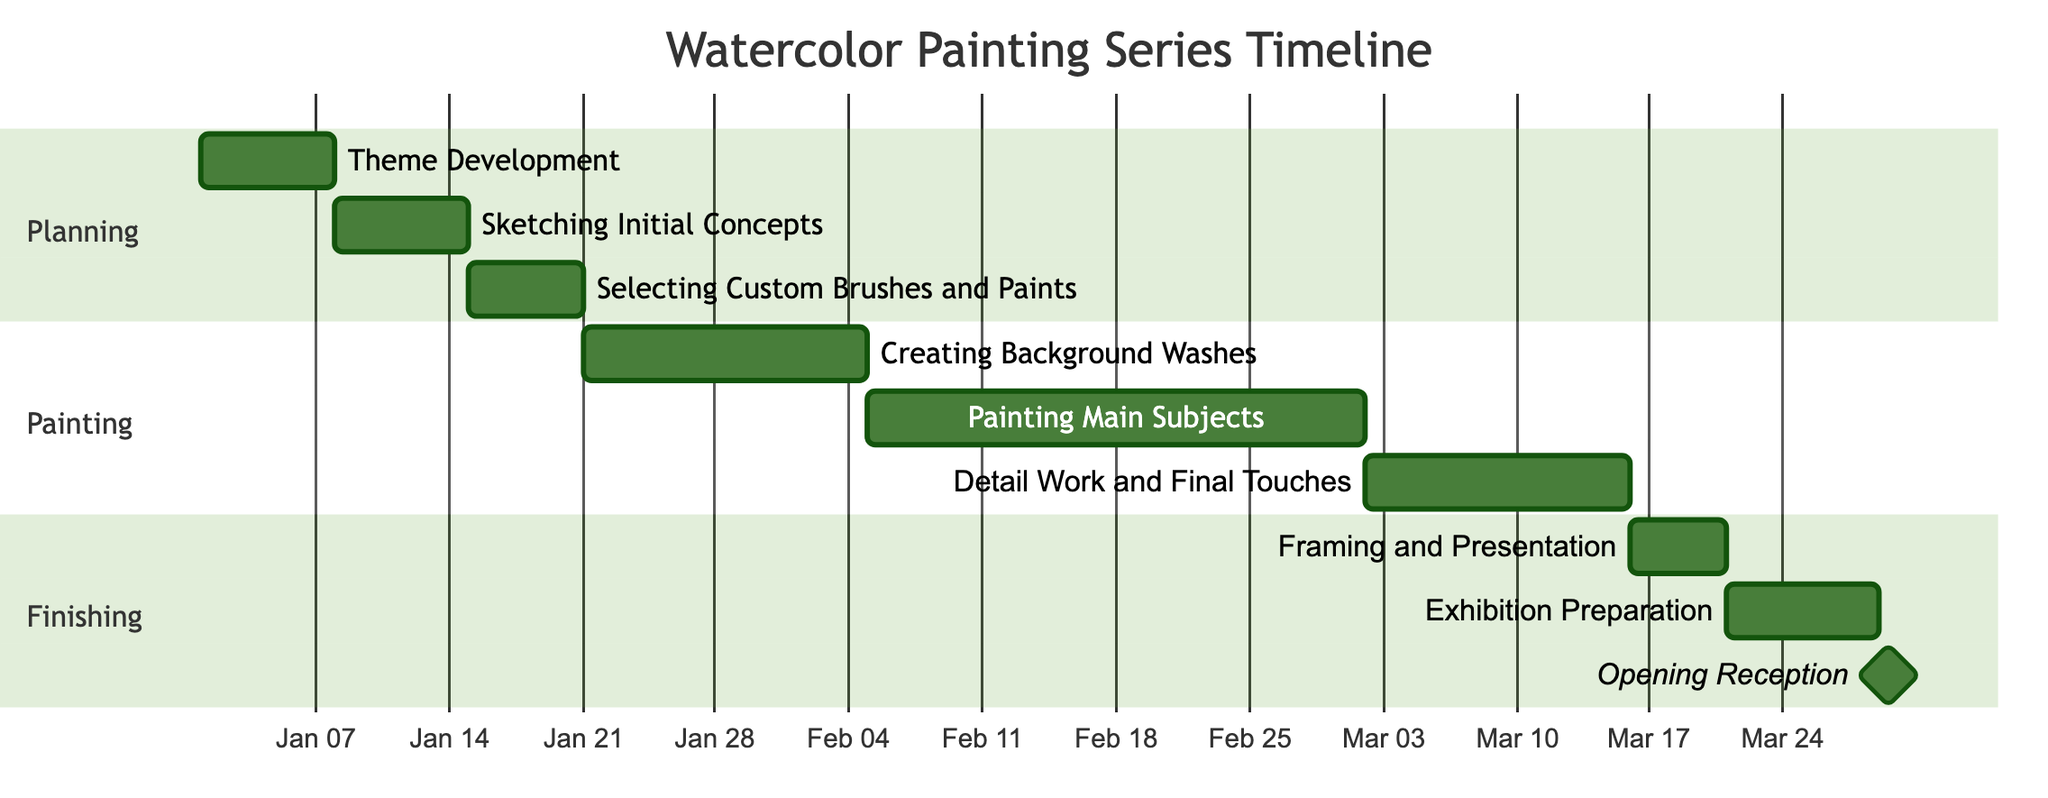What is the duration of the "Theme Development" task? The "Theme Development" task starts on January 1, 2024, and ends on January 7, 2024. This gives it a duration of 7 days.
Answer: 7 days How many tasks are in the "Painting" section? The "Painting" section includes three tasks: "Creating Background Washes," "Painting Main Subjects," and "Detail Work and Final Touches." Therefore, there are 3 tasks in this section.
Answer: 3 tasks What is the end date of the "Selecting Custom Brushes and Paints" task? The "Selecting Custom Brushes and Paints" task starts on January 15, 2024, and ends on January 20, 2024. Thus, the end date is January 20, 2024.
Answer: January 20, 2024 Which task follows "Detail Work and Final Touches"? After "Detail Work and Final Touches," the next task is "Framing and Presentation," as it is directly sequenced after it in the timeline.
Answer: Framing and Presentation How long is the gap between "Exhibition Preparation" and "Opening Reception"? "Exhibition Preparation" ends on March 28, 2024, while "Opening Reception" starts and ends on March 29, 2024, indicating there is no gap; they occur on consecutive days.
Answer: No gap Which section has the longest task duration? The longest task duration belongs to the "Painting" section with "Painting Main Subjects," lasting for 26 days from February 5, 2024, to March 1, 2024.
Answer: Painting Main Subjects How many total days does the "Watercolor Painting Series" project last? The project starts on January 1, 2024, and culminates on March 29, 2024. Calculating the total duration from the start to the end date gives us 88 days.
Answer: 88 days What is the start date of "Framing and Presentation"? Referring to the timeline, "Framing and Presentation" starts immediately after "Detail Work and Final Touches," on March 16, 2024.
Answer: March 16, 2024 